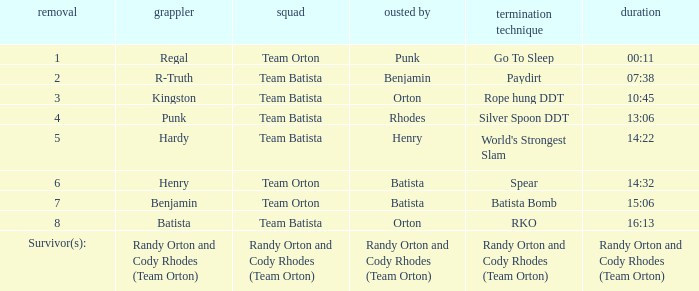What Elimination Move is listed against Wrestler Henry, Eliminated by Batista? Spear. 